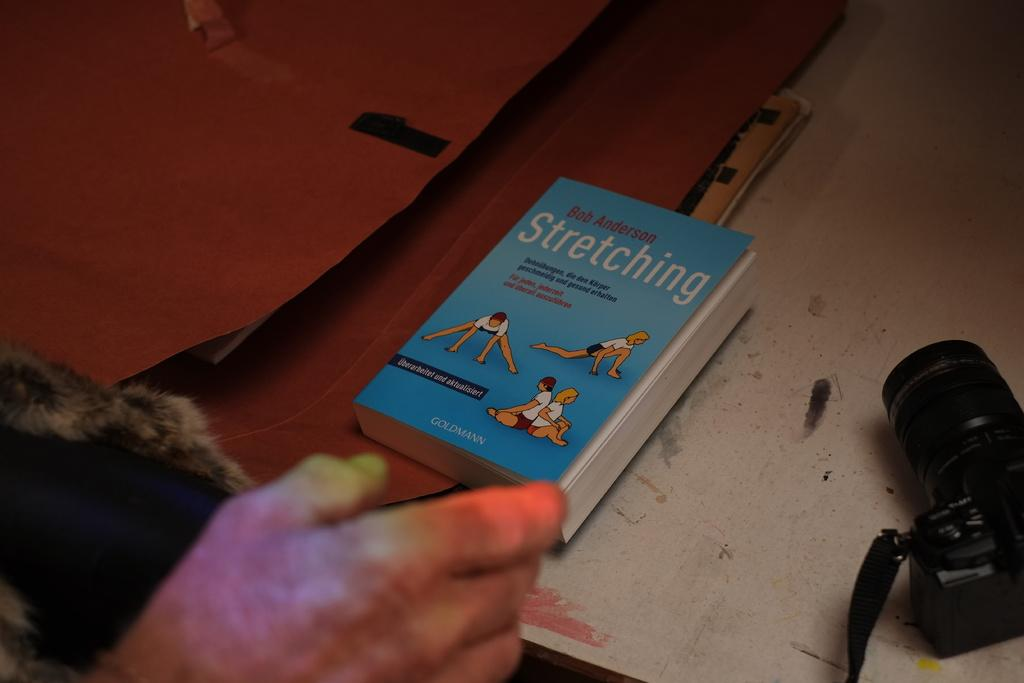<image>
Present a compact description of the photo's key features. A book about stretching written by Bob Anderson. 